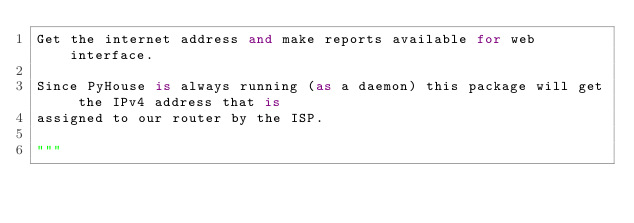Convert code to text. <code><loc_0><loc_0><loc_500><loc_500><_Python_>Get the internet address and make reports available for web interface.

Since PyHouse is always running (as a daemon) this package will get the IPv4 address that is
assigned to our router by the ISP.

"""</code> 